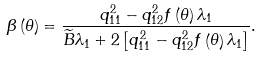<formula> <loc_0><loc_0><loc_500><loc_500>\beta \left ( \theta \right ) = \frac { q _ { 1 1 } ^ { 2 } - q _ { 1 2 } ^ { 2 } f \left ( \theta \right ) \lambda _ { 1 } } { \widetilde { B } \lambda _ { 1 } + 2 \left [ q _ { 1 1 } ^ { 2 } - q _ { 1 2 } ^ { 2 } f \left ( \theta \right ) \lambda _ { 1 } \right ] } .</formula> 